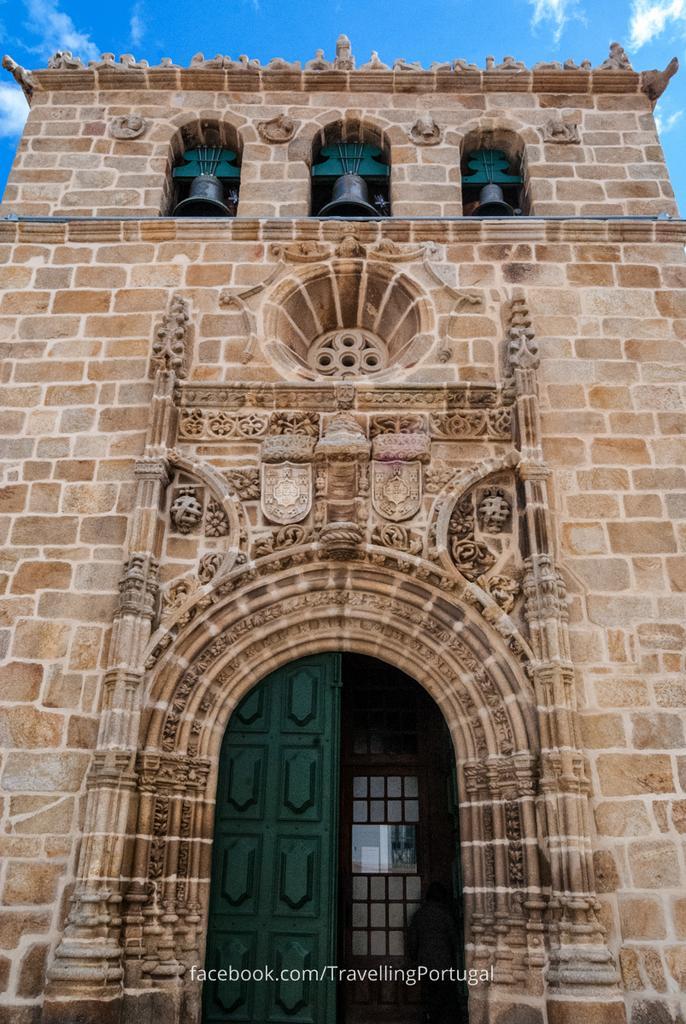How would you summarize this image in a sentence or two? In this picture we can see a building. There are three bells and few arches on this building. We can see a green door on this building. Sky is blue in color and cloudy. 